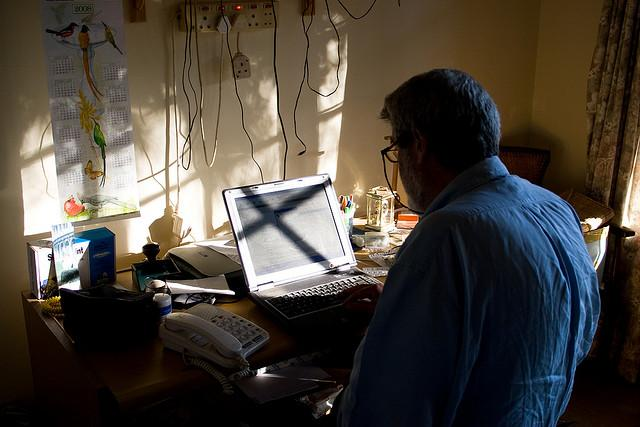What is the man using the computer to do? work 